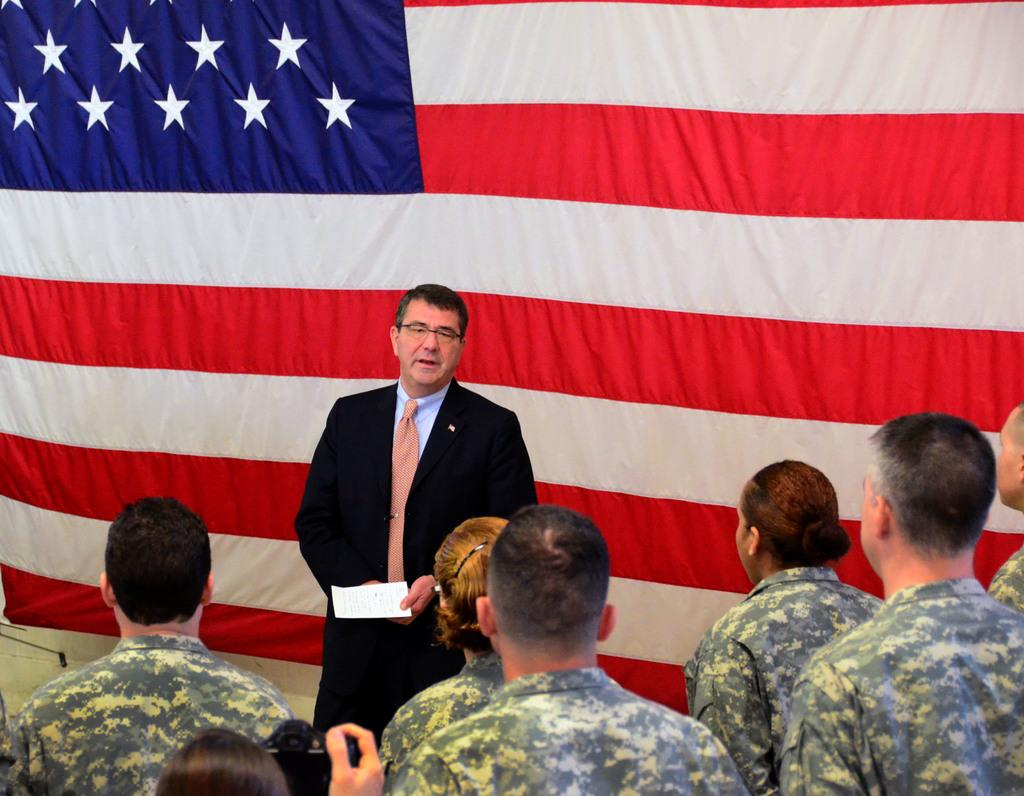What is hanging on the wall in the image? There is a flag on the wall in the image. Who is standing in front of the flag? There is a man in a black suit standing in front of the flag. How many people are standing in front of the man in the black suit? There are many people standing in front of the man in the black suit. What are the people doing in the image? The people are staring at the man in the black suit. Can you tell me how many snails are crawling on the man in the black suit? There are no snails present in the image; the man in the black suit is standing in front of a flag with people staring at him. 